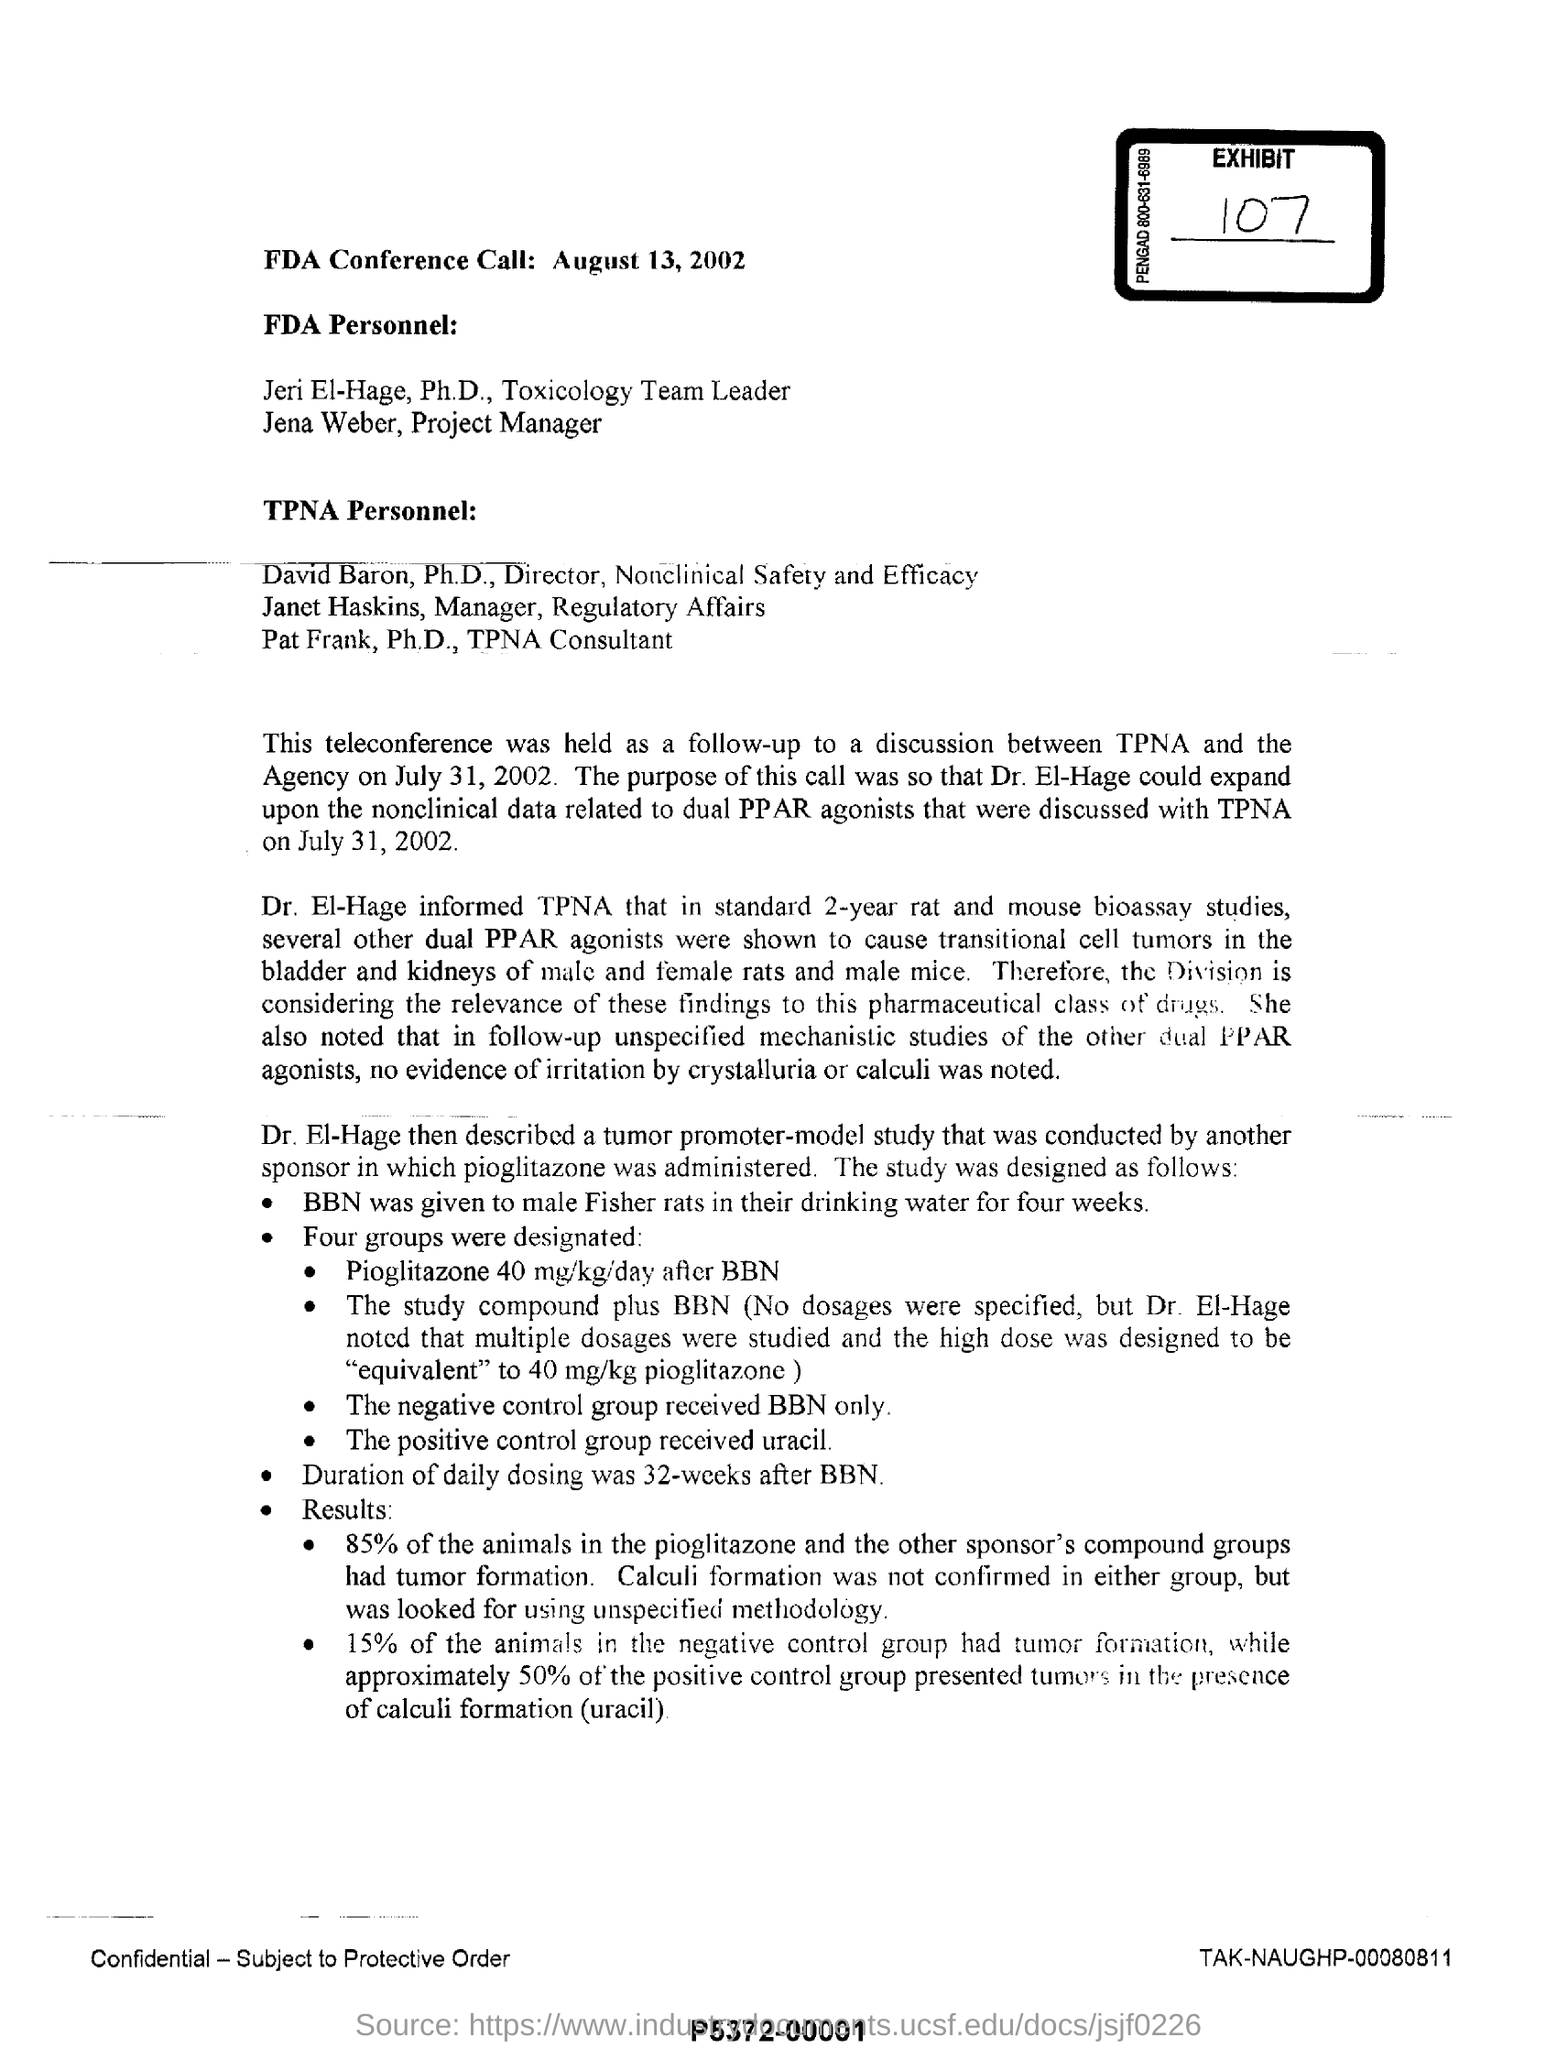Can you describe the significance of using dual PPAR agonists in the studies? Dual PPAR agonists, like pioglitazone, are significant as they have been shown in multiple studies, including this one, to cause transitional cell tumors in animals. This relevance is particularly critical when considering the safety and effects of these pharmaceuticals on male versus female rats. 